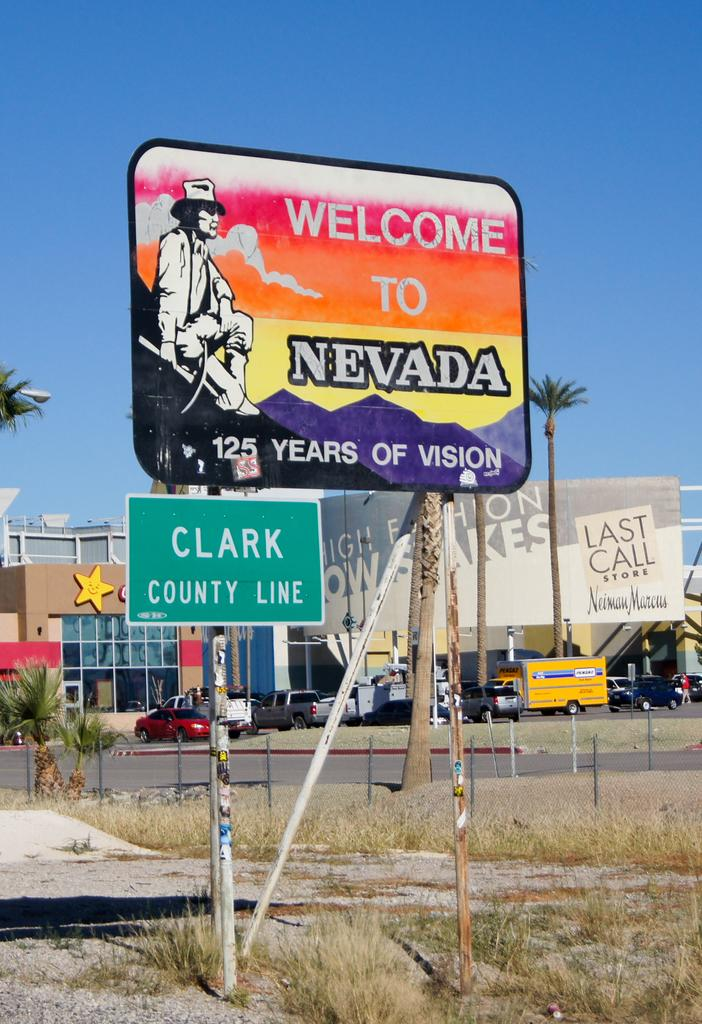<image>
Write a terse but informative summary of the picture. The Clark County Line is on the Nevada border. 